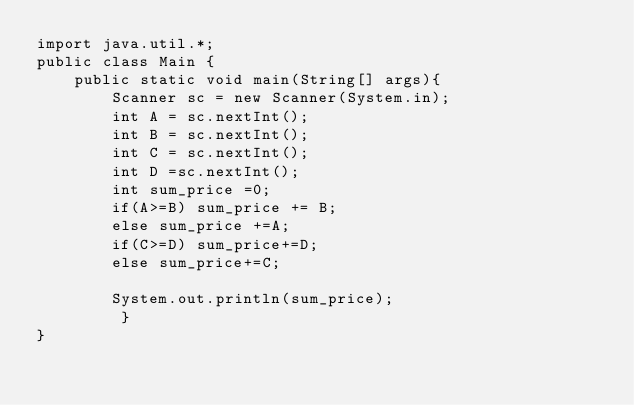Convert code to text. <code><loc_0><loc_0><loc_500><loc_500><_Java_>import java.util.*;
public class Main {
    public static void main(String[] args){
        Scanner sc = new Scanner(System.in);
        int A = sc.nextInt();
        int B = sc.nextInt();
        int C = sc.nextInt();
        int D =sc.nextInt();
        int sum_price =0;
        if(A>=B) sum_price += B;
        else sum_price +=A;
        if(C>=D) sum_price+=D;
        else sum_price+=C;

        System.out.println(sum_price);
         }
}</code> 